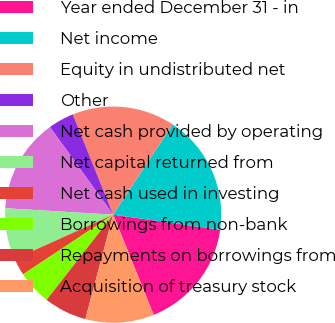<chart> <loc_0><loc_0><loc_500><loc_500><pie_chart><fcel>Year ended December 31 - in<fcel>Net income<fcel>Equity in undistributed net<fcel>Other<fcel>Net cash provided by operating<fcel>Net capital returned from<fcel>Net cash used in investing<fcel>Borrowings from non-bank<fcel>Repayments on borrowings from<fcel>Acquisition of treasury stock<nl><fcel>16.66%<fcel>17.94%<fcel>15.38%<fcel>3.85%<fcel>14.1%<fcel>7.69%<fcel>2.57%<fcel>5.13%<fcel>6.41%<fcel>10.26%<nl></chart> 